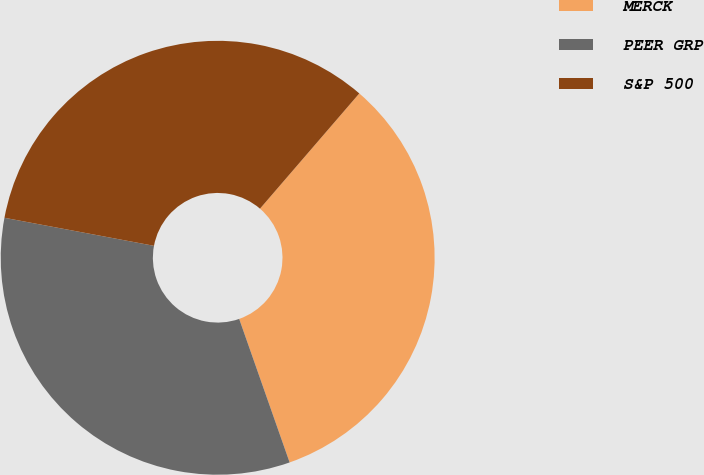<chart> <loc_0><loc_0><loc_500><loc_500><pie_chart><fcel>MERCK<fcel>PEER GRP<fcel>S&P 500<nl><fcel>33.3%<fcel>33.33%<fcel>33.37%<nl></chart> 